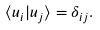Convert formula to latex. <formula><loc_0><loc_0><loc_500><loc_500>\langle u _ { i } | u _ { j } \rangle = \delta _ { i j } .</formula> 